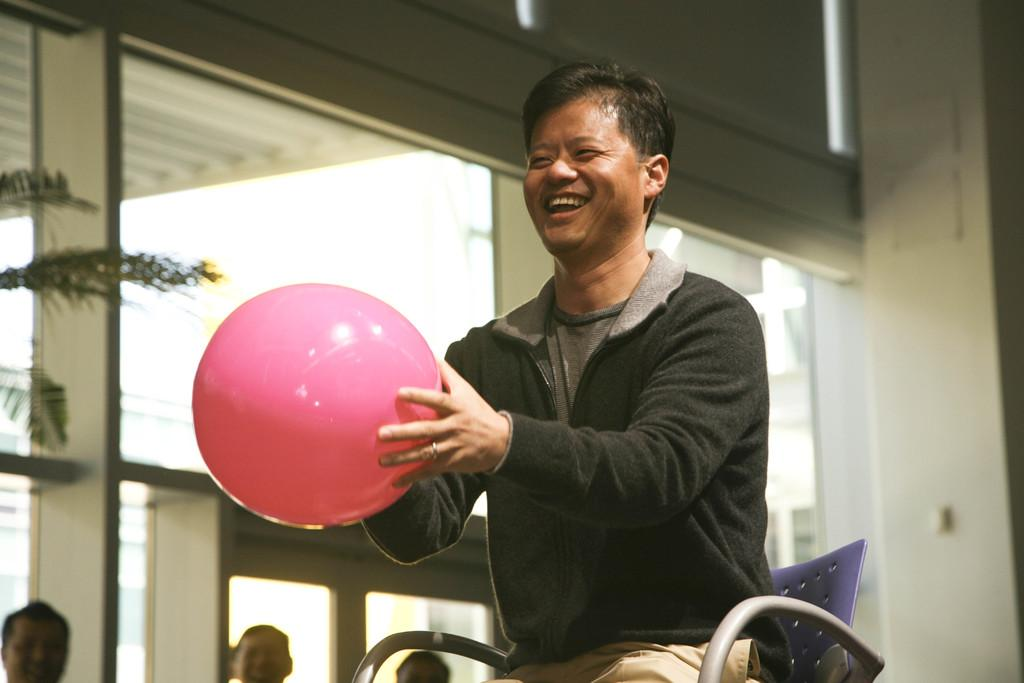What is the main subject of the image? There is a person sitting in a chair in the center of the image. What is the person holding in the image? The person is holding a ball. What can be seen on the left side of the image? There is a tree on the left side of the image. What is visible in the background of the image? There are people and buildings in the background of the image. What type of fruit is hanging from the tree in the image? There is no fruit hanging from the tree in the image; it is a tree without any visible fruit. What is the person wearing around their neck in the image? There is no mention of a locket or any necklace in the image; the person is simply holding a ball. 